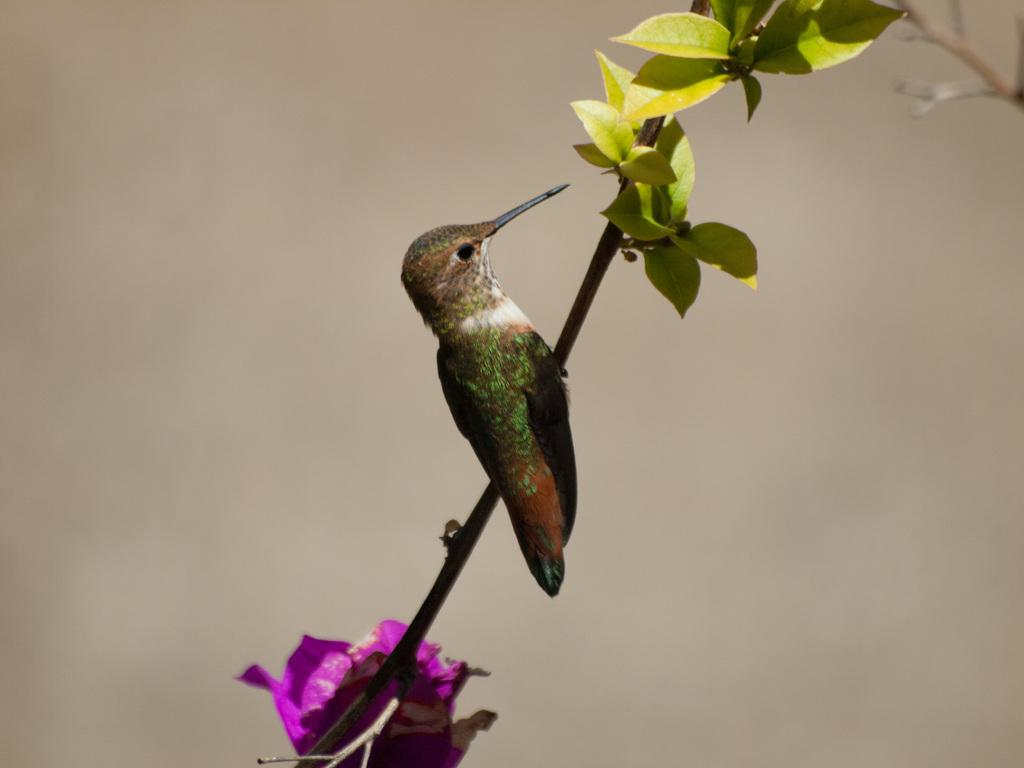What type of animal is in the image? There is a hummingbird in the image. Where is the hummingbird located in the image? The hummingbird is standing on the stem of a plant. What color is the flower in the image? The flower in the image is purple in color. What can be seen at the top of the plant? The plant has leaves at the top. How many legs does the pencil have in the image? There is no pencil present in the image, so it is not possible to determine the number of legs it might have. 